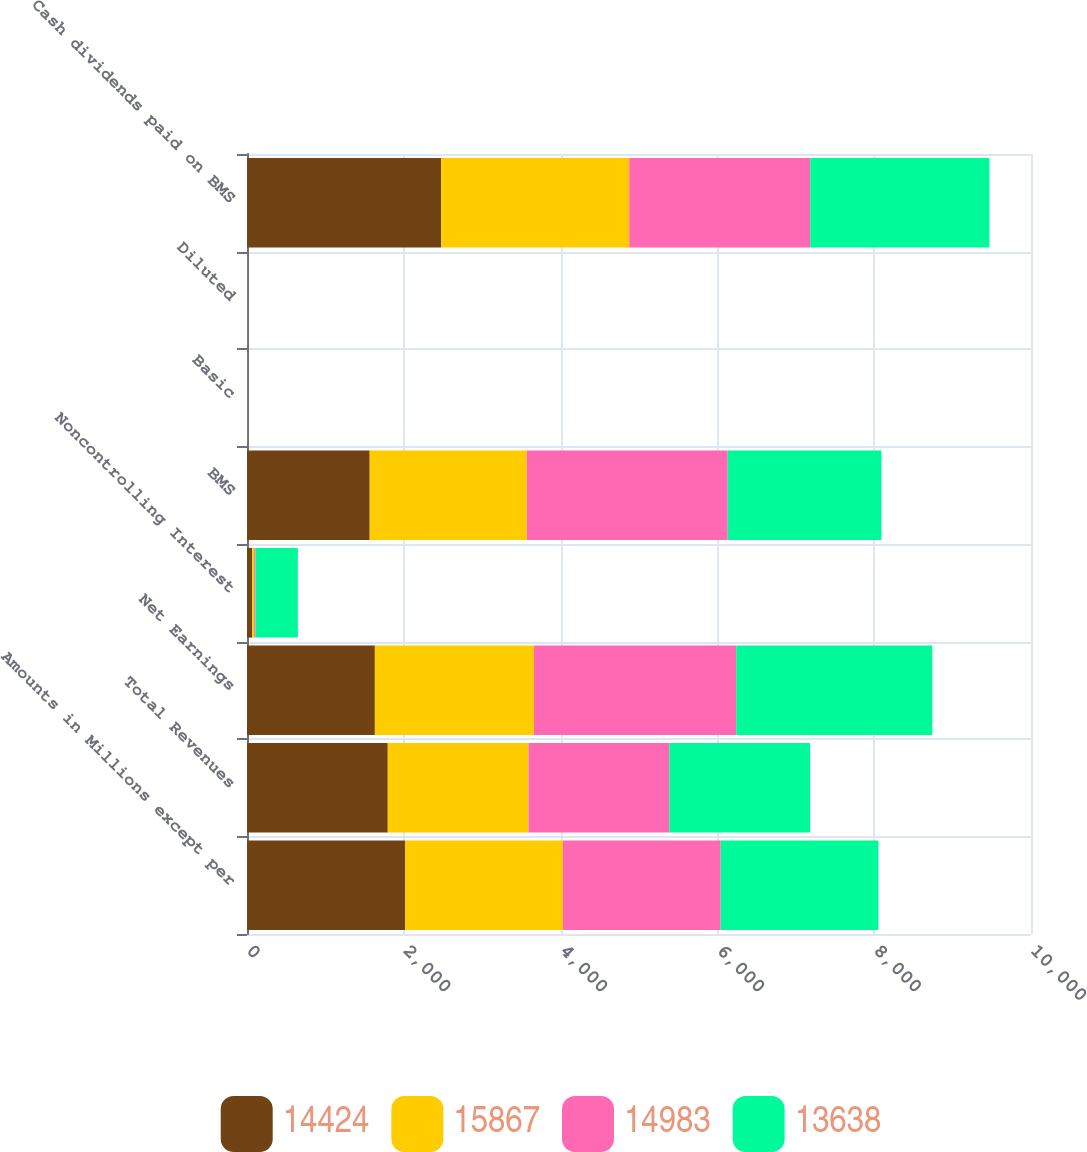<chart> <loc_0><loc_0><loc_500><loc_500><stacked_bar_chart><ecel><fcel>Amounts in Millions except per<fcel>Total Revenues<fcel>Net Earnings<fcel>Noncontrolling Interest<fcel>BMS<fcel>Basic<fcel>Diluted<fcel>Cash dividends paid on BMS<nl><fcel>14424<fcel>2015<fcel>1795.5<fcel>1631<fcel>66<fcel>1565<fcel>0.94<fcel>0.93<fcel>2477<nl><fcel>15867<fcel>2014<fcel>1795.5<fcel>2029<fcel>25<fcel>2004<fcel>1.21<fcel>1.2<fcel>2398<nl><fcel>14983<fcel>2013<fcel>1795.5<fcel>2580<fcel>17<fcel>2563<fcel>1.56<fcel>1.54<fcel>2309<nl><fcel>13638<fcel>2012<fcel>1795.5<fcel>2501<fcel>541<fcel>1960<fcel>1.17<fcel>1.16<fcel>2286<nl></chart> 